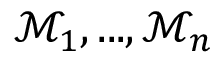Convert formula to latex. <formula><loc_0><loc_0><loc_500><loc_500>\mathcal { M } _ { 1 } , \dots , \mathcal { M } _ { n }</formula> 